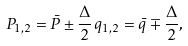<formula> <loc_0><loc_0><loc_500><loc_500>P _ { 1 , 2 } = \bar { P } \pm \frac { \Delta } { 2 } \, q _ { 1 , 2 } = \bar { q } \mp \frac { \Delta } { 2 } ,</formula> 